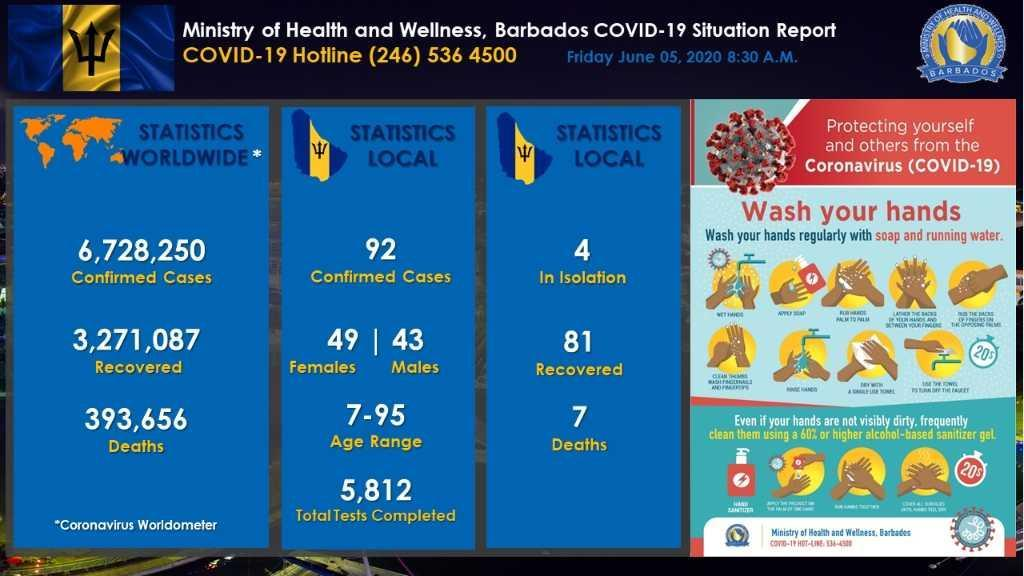How much time to take to santise the hands properly
Answer the question with a short phrase. 20s What is the total number of confirmed cases and deaths globally? 7121906 Who is more infected locally - men or women? women what is the difference between number of infected cases of men and women? 6 what is the difference between number of deaths and recovered cases locally? 88 what is the difference between number of deaths and recovered cases globally? 3664743 what is the difference between number of confirmed cases and recovered cases locally? 11 How many steps in the 20s hand washing process 9 what is the total number of confirmed cases and deaths locally? 99 